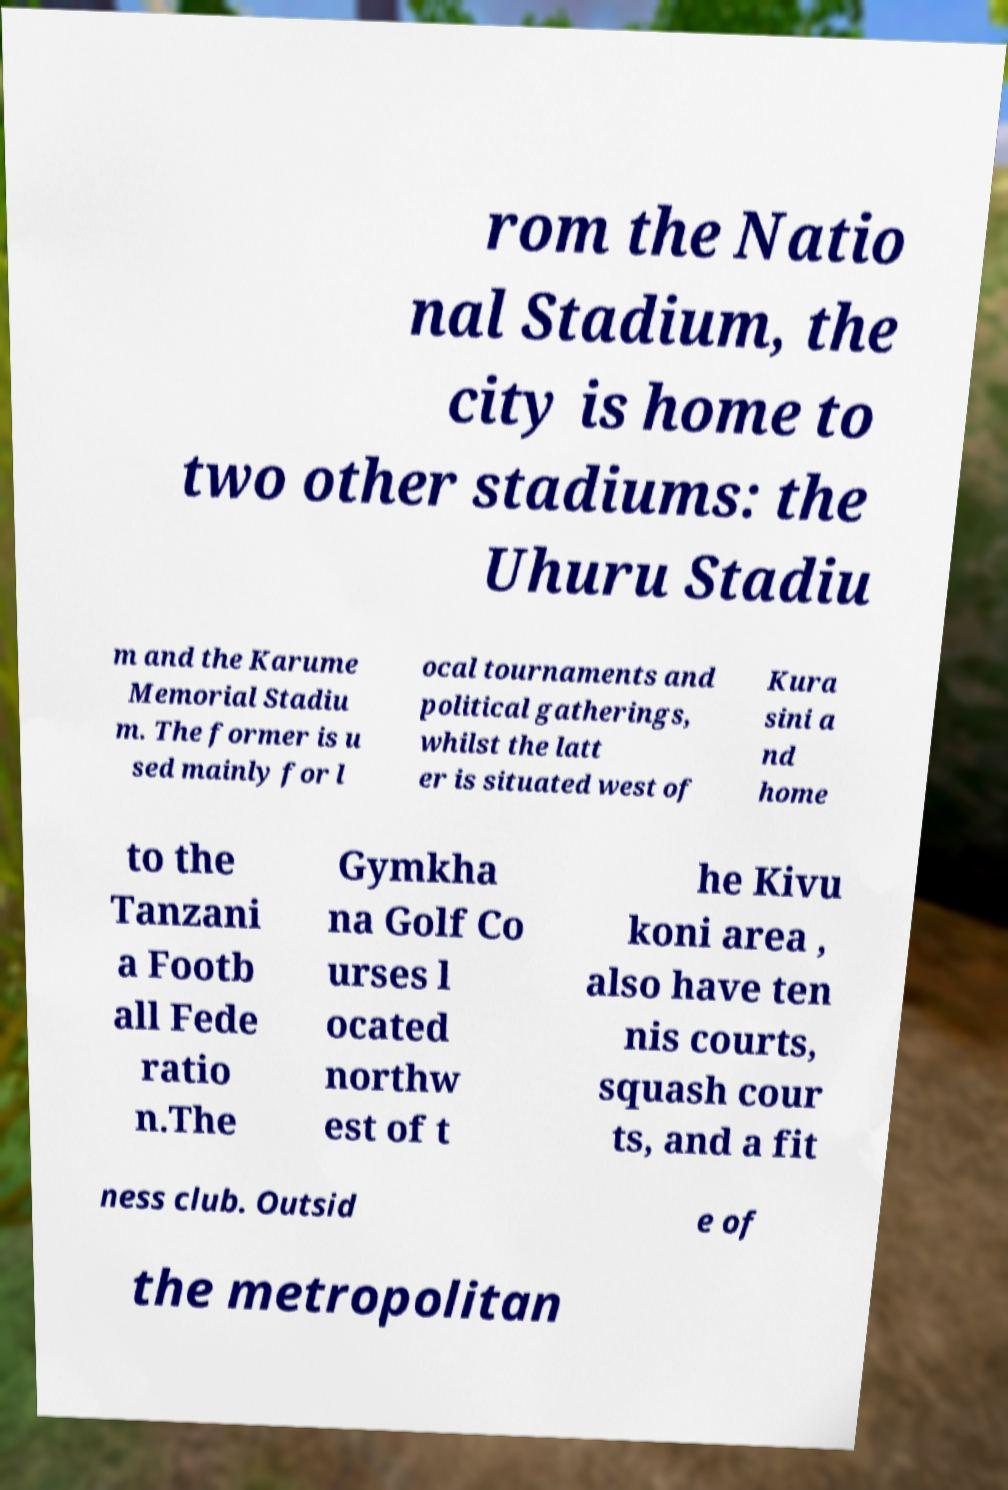What messages or text are displayed in this image? I need them in a readable, typed format. rom the Natio nal Stadium, the city is home to two other stadiums: the Uhuru Stadiu m and the Karume Memorial Stadiu m. The former is u sed mainly for l ocal tournaments and political gatherings, whilst the latt er is situated west of Kura sini a nd home to the Tanzani a Footb all Fede ratio n.The Gymkha na Golf Co urses l ocated northw est of t he Kivu koni area , also have ten nis courts, squash cour ts, and a fit ness club. Outsid e of the metropolitan 